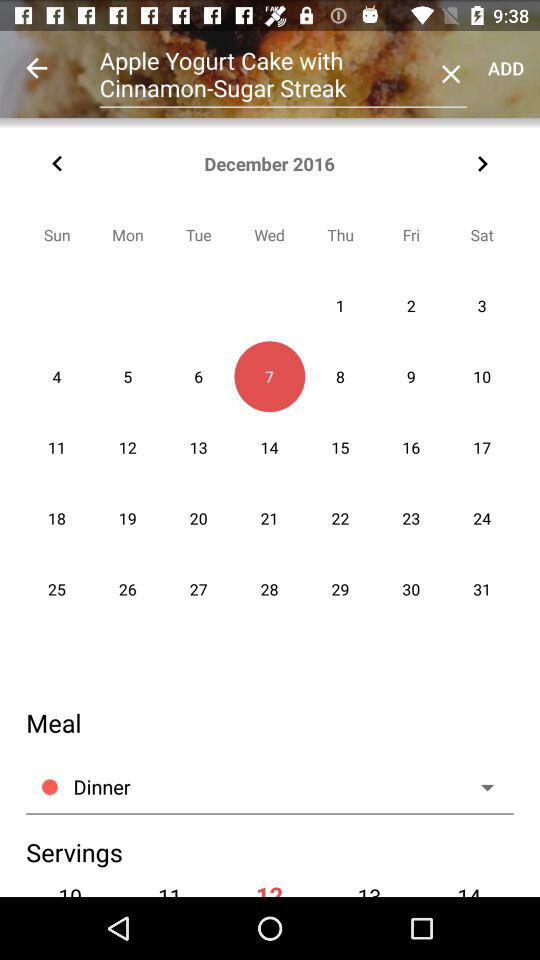What is the given month? The given month is December. 